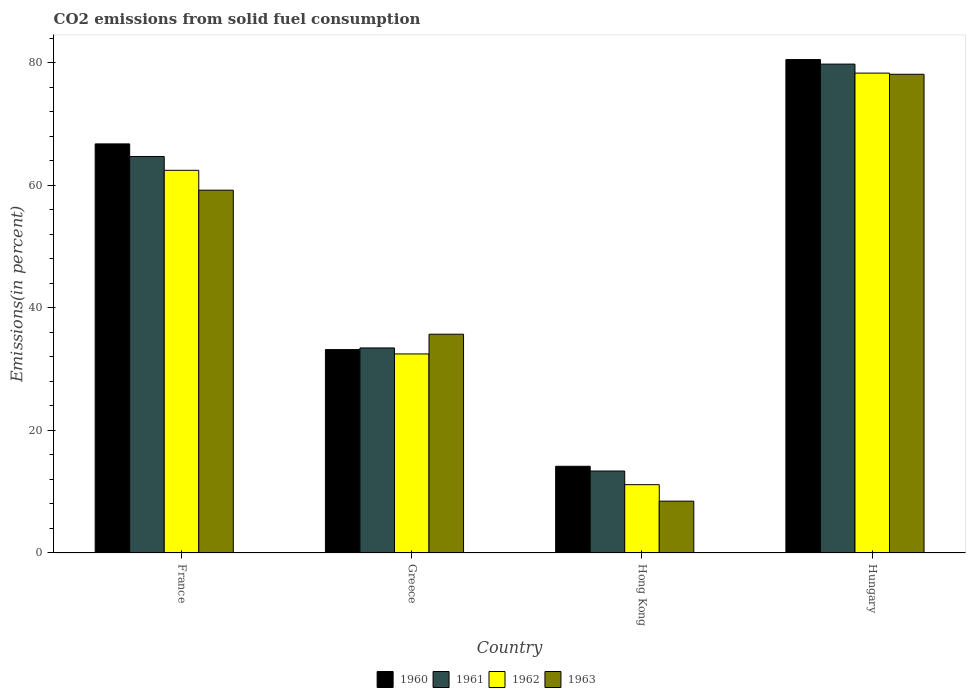How many different coloured bars are there?
Give a very brief answer. 4. Are the number of bars per tick equal to the number of legend labels?
Ensure brevity in your answer.  Yes. Are the number of bars on each tick of the X-axis equal?
Provide a succinct answer. Yes. How many bars are there on the 1st tick from the left?
Your answer should be compact. 4. What is the label of the 1st group of bars from the left?
Your answer should be compact. France. In how many cases, is the number of bars for a given country not equal to the number of legend labels?
Make the answer very short. 0. What is the total CO2 emitted in 1962 in Hungary?
Make the answer very short. 78.28. Across all countries, what is the maximum total CO2 emitted in 1961?
Provide a short and direct response. 79.75. Across all countries, what is the minimum total CO2 emitted in 1961?
Keep it short and to the point. 13.37. In which country was the total CO2 emitted in 1962 maximum?
Provide a succinct answer. Hungary. In which country was the total CO2 emitted in 1962 minimum?
Give a very brief answer. Hong Kong. What is the total total CO2 emitted in 1963 in the graph?
Ensure brevity in your answer.  181.41. What is the difference between the total CO2 emitted in 1960 in France and that in Greece?
Give a very brief answer. 33.55. What is the difference between the total CO2 emitted in 1962 in Hungary and the total CO2 emitted in 1960 in France?
Your answer should be compact. 11.55. What is the average total CO2 emitted in 1963 per country?
Offer a terse response. 45.35. What is the difference between the total CO2 emitted of/in 1960 and total CO2 emitted of/in 1961 in Greece?
Keep it short and to the point. -0.27. In how many countries, is the total CO2 emitted in 1962 greater than 16 %?
Keep it short and to the point. 3. What is the ratio of the total CO2 emitted in 1963 in Greece to that in Hong Kong?
Your response must be concise. 4.22. Is the difference between the total CO2 emitted in 1960 in Greece and Hong Kong greater than the difference between the total CO2 emitted in 1961 in Greece and Hong Kong?
Keep it short and to the point. No. What is the difference between the highest and the second highest total CO2 emitted in 1960?
Your answer should be compact. 47.31. What is the difference between the highest and the lowest total CO2 emitted in 1963?
Keep it short and to the point. 69.63. How many bars are there?
Offer a terse response. 16. Does the graph contain any zero values?
Offer a terse response. No. Does the graph contain grids?
Provide a short and direct response. No. How are the legend labels stacked?
Make the answer very short. Horizontal. What is the title of the graph?
Make the answer very short. CO2 emissions from solid fuel consumption. Does "1971" appear as one of the legend labels in the graph?
Give a very brief answer. No. What is the label or title of the Y-axis?
Ensure brevity in your answer.  Emissions(in percent). What is the Emissions(in percent) of 1960 in France?
Give a very brief answer. 66.73. What is the Emissions(in percent) in 1961 in France?
Offer a terse response. 64.68. What is the Emissions(in percent) of 1962 in France?
Ensure brevity in your answer.  62.42. What is the Emissions(in percent) in 1963 in France?
Provide a succinct answer. 59.18. What is the Emissions(in percent) in 1960 in Greece?
Ensure brevity in your answer.  33.18. What is the Emissions(in percent) of 1961 in Greece?
Provide a succinct answer. 33.45. What is the Emissions(in percent) of 1962 in Greece?
Provide a short and direct response. 32.47. What is the Emissions(in percent) of 1963 in Greece?
Your answer should be very brief. 35.69. What is the Emissions(in percent) of 1960 in Hong Kong?
Offer a terse response. 14.14. What is the Emissions(in percent) in 1961 in Hong Kong?
Your answer should be very brief. 13.37. What is the Emissions(in percent) of 1962 in Hong Kong?
Provide a succinct answer. 11.14. What is the Emissions(in percent) of 1963 in Hong Kong?
Your response must be concise. 8.46. What is the Emissions(in percent) in 1960 in Hungary?
Make the answer very short. 80.49. What is the Emissions(in percent) of 1961 in Hungary?
Give a very brief answer. 79.75. What is the Emissions(in percent) in 1962 in Hungary?
Keep it short and to the point. 78.28. What is the Emissions(in percent) in 1963 in Hungary?
Offer a terse response. 78.09. Across all countries, what is the maximum Emissions(in percent) of 1960?
Provide a short and direct response. 80.49. Across all countries, what is the maximum Emissions(in percent) in 1961?
Ensure brevity in your answer.  79.75. Across all countries, what is the maximum Emissions(in percent) in 1962?
Provide a succinct answer. 78.28. Across all countries, what is the maximum Emissions(in percent) in 1963?
Offer a very short reply. 78.09. Across all countries, what is the minimum Emissions(in percent) of 1960?
Provide a succinct answer. 14.14. Across all countries, what is the minimum Emissions(in percent) of 1961?
Your response must be concise. 13.37. Across all countries, what is the minimum Emissions(in percent) in 1962?
Provide a short and direct response. 11.14. Across all countries, what is the minimum Emissions(in percent) in 1963?
Your answer should be very brief. 8.46. What is the total Emissions(in percent) in 1960 in the graph?
Ensure brevity in your answer.  194.54. What is the total Emissions(in percent) in 1961 in the graph?
Provide a succinct answer. 191.24. What is the total Emissions(in percent) of 1962 in the graph?
Provide a succinct answer. 184.31. What is the total Emissions(in percent) of 1963 in the graph?
Offer a very short reply. 181.41. What is the difference between the Emissions(in percent) of 1960 in France and that in Greece?
Your response must be concise. 33.55. What is the difference between the Emissions(in percent) in 1961 in France and that in Greece?
Keep it short and to the point. 31.23. What is the difference between the Emissions(in percent) in 1962 in France and that in Greece?
Your response must be concise. 29.95. What is the difference between the Emissions(in percent) of 1963 in France and that in Greece?
Your answer should be very brief. 23.49. What is the difference between the Emissions(in percent) in 1960 in France and that in Hong Kong?
Keep it short and to the point. 52.59. What is the difference between the Emissions(in percent) in 1961 in France and that in Hong Kong?
Offer a terse response. 51.31. What is the difference between the Emissions(in percent) in 1962 in France and that in Hong Kong?
Make the answer very short. 51.28. What is the difference between the Emissions(in percent) in 1963 in France and that in Hong Kong?
Your response must be concise. 50.73. What is the difference between the Emissions(in percent) of 1960 in France and that in Hungary?
Ensure brevity in your answer.  -13.76. What is the difference between the Emissions(in percent) in 1961 in France and that in Hungary?
Your answer should be very brief. -15.07. What is the difference between the Emissions(in percent) in 1962 in France and that in Hungary?
Offer a very short reply. -15.86. What is the difference between the Emissions(in percent) in 1963 in France and that in Hungary?
Offer a very short reply. -18.91. What is the difference between the Emissions(in percent) of 1960 in Greece and that in Hong Kong?
Give a very brief answer. 19.03. What is the difference between the Emissions(in percent) in 1961 in Greece and that in Hong Kong?
Your answer should be compact. 20.08. What is the difference between the Emissions(in percent) of 1962 in Greece and that in Hong Kong?
Your answer should be compact. 21.32. What is the difference between the Emissions(in percent) of 1963 in Greece and that in Hong Kong?
Keep it short and to the point. 27.23. What is the difference between the Emissions(in percent) in 1960 in Greece and that in Hungary?
Keep it short and to the point. -47.31. What is the difference between the Emissions(in percent) of 1961 in Greece and that in Hungary?
Your response must be concise. -46.3. What is the difference between the Emissions(in percent) of 1962 in Greece and that in Hungary?
Offer a terse response. -45.81. What is the difference between the Emissions(in percent) in 1963 in Greece and that in Hungary?
Your response must be concise. -42.4. What is the difference between the Emissions(in percent) of 1960 in Hong Kong and that in Hungary?
Give a very brief answer. -66.35. What is the difference between the Emissions(in percent) of 1961 in Hong Kong and that in Hungary?
Provide a short and direct response. -66.38. What is the difference between the Emissions(in percent) in 1962 in Hong Kong and that in Hungary?
Offer a very short reply. -67.13. What is the difference between the Emissions(in percent) of 1963 in Hong Kong and that in Hungary?
Provide a succinct answer. -69.63. What is the difference between the Emissions(in percent) of 1960 in France and the Emissions(in percent) of 1961 in Greece?
Keep it short and to the point. 33.29. What is the difference between the Emissions(in percent) in 1960 in France and the Emissions(in percent) in 1962 in Greece?
Your answer should be very brief. 34.26. What is the difference between the Emissions(in percent) of 1960 in France and the Emissions(in percent) of 1963 in Greece?
Give a very brief answer. 31.05. What is the difference between the Emissions(in percent) of 1961 in France and the Emissions(in percent) of 1962 in Greece?
Offer a terse response. 32.21. What is the difference between the Emissions(in percent) in 1961 in France and the Emissions(in percent) in 1963 in Greece?
Provide a succinct answer. 28.99. What is the difference between the Emissions(in percent) of 1962 in France and the Emissions(in percent) of 1963 in Greece?
Provide a short and direct response. 26.74. What is the difference between the Emissions(in percent) of 1960 in France and the Emissions(in percent) of 1961 in Hong Kong?
Keep it short and to the point. 53.36. What is the difference between the Emissions(in percent) of 1960 in France and the Emissions(in percent) of 1962 in Hong Kong?
Ensure brevity in your answer.  55.59. What is the difference between the Emissions(in percent) of 1960 in France and the Emissions(in percent) of 1963 in Hong Kong?
Offer a terse response. 58.28. What is the difference between the Emissions(in percent) of 1961 in France and the Emissions(in percent) of 1962 in Hong Kong?
Offer a terse response. 53.53. What is the difference between the Emissions(in percent) in 1961 in France and the Emissions(in percent) in 1963 in Hong Kong?
Make the answer very short. 56.22. What is the difference between the Emissions(in percent) of 1962 in France and the Emissions(in percent) of 1963 in Hong Kong?
Your answer should be very brief. 53.97. What is the difference between the Emissions(in percent) in 1960 in France and the Emissions(in percent) in 1961 in Hungary?
Your answer should be very brief. -13.02. What is the difference between the Emissions(in percent) in 1960 in France and the Emissions(in percent) in 1962 in Hungary?
Provide a short and direct response. -11.55. What is the difference between the Emissions(in percent) in 1960 in France and the Emissions(in percent) in 1963 in Hungary?
Your answer should be compact. -11.36. What is the difference between the Emissions(in percent) of 1961 in France and the Emissions(in percent) of 1962 in Hungary?
Give a very brief answer. -13.6. What is the difference between the Emissions(in percent) of 1961 in France and the Emissions(in percent) of 1963 in Hungary?
Your answer should be compact. -13.41. What is the difference between the Emissions(in percent) of 1962 in France and the Emissions(in percent) of 1963 in Hungary?
Keep it short and to the point. -15.67. What is the difference between the Emissions(in percent) of 1960 in Greece and the Emissions(in percent) of 1961 in Hong Kong?
Keep it short and to the point. 19.81. What is the difference between the Emissions(in percent) in 1960 in Greece and the Emissions(in percent) in 1962 in Hong Kong?
Your answer should be very brief. 22.03. What is the difference between the Emissions(in percent) of 1960 in Greece and the Emissions(in percent) of 1963 in Hong Kong?
Your response must be concise. 24.72. What is the difference between the Emissions(in percent) in 1961 in Greece and the Emissions(in percent) in 1962 in Hong Kong?
Your answer should be compact. 22.3. What is the difference between the Emissions(in percent) in 1961 in Greece and the Emissions(in percent) in 1963 in Hong Kong?
Make the answer very short. 24.99. What is the difference between the Emissions(in percent) in 1962 in Greece and the Emissions(in percent) in 1963 in Hong Kong?
Give a very brief answer. 24.01. What is the difference between the Emissions(in percent) in 1960 in Greece and the Emissions(in percent) in 1961 in Hungary?
Provide a short and direct response. -46.57. What is the difference between the Emissions(in percent) in 1960 in Greece and the Emissions(in percent) in 1962 in Hungary?
Offer a very short reply. -45.1. What is the difference between the Emissions(in percent) in 1960 in Greece and the Emissions(in percent) in 1963 in Hungary?
Provide a succinct answer. -44.91. What is the difference between the Emissions(in percent) of 1961 in Greece and the Emissions(in percent) of 1962 in Hungary?
Offer a terse response. -44.83. What is the difference between the Emissions(in percent) of 1961 in Greece and the Emissions(in percent) of 1963 in Hungary?
Keep it short and to the point. -44.64. What is the difference between the Emissions(in percent) of 1962 in Greece and the Emissions(in percent) of 1963 in Hungary?
Your answer should be compact. -45.62. What is the difference between the Emissions(in percent) of 1960 in Hong Kong and the Emissions(in percent) of 1961 in Hungary?
Keep it short and to the point. -65.6. What is the difference between the Emissions(in percent) of 1960 in Hong Kong and the Emissions(in percent) of 1962 in Hungary?
Keep it short and to the point. -64.13. What is the difference between the Emissions(in percent) of 1960 in Hong Kong and the Emissions(in percent) of 1963 in Hungary?
Offer a terse response. -63.94. What is the difference between the Emissions(in percent) in 1961 in Hong Kong and the Emissions(in percent) in 1962 in Hungary?
Your response must be concise. -64.91. What is the difference between the Emissions(in percent) in 1961 in Hong Kong and the Emissions(in percent) in 1963 in Hungary?
Your response must be concise. -64.72. What is the difference between the Emissions(in percent) in 1962 in Hong Kong and the Emissions(in percent) in 1963 in Hungary?
Your answer should be compact. -66.94. What is the average Emissions(in percent) in 1960 per country?
Your answer should be compact. 48.64. What is the average Emissions(in percent) in 1961 per country?
Offer a very short reply. 47.81. What is the average Emissions(in percent) of 1962 per country?
Provide a succinct answer. 46.08. What is the average Emissions(in percent) of 1963 per country?
Ensure brevity in your answer.  45.35. What is the difference between the Emissions(in percent) of 1960 and Emissions(in percent) of 1961 in France?
Provide a short and direct response. 2.06. What is the difference between the Emissions(in percent) in 1960 and Emissions(in percent) in 1962 in France?
Provide a succinct answer. 4.31. What is the difference between the Emissions(in percent) of 1960 and Emissions(in percent) of 1963 in France?
Ensure brevity in your answer.  7.55. What is the difference between the Emissions(in percent) of 1961 and Emissions(in percent) of 1962 in France?
Offer a terse response. 2.25. What is the difference between the Emissions(in percent) of 1961 and Emissions(in percent) of 1963 in France?
Offer a terse response. 5.49. What is the difference between the Emissions(in percent) of 1962 and Emissions(in percent) of 1963 in France?
Provide a short and direct response. 3.24. What is the difference between the Emissions(in percent) in 1960 and Emissions(in percent) in 1961 in Greece?
Make the answer very short. -0.27. What is the difference between the Emissions(in percent) in 1960 and Emissions(in percent) in 1962 in Greece?
Ensure brevity in your answer.  0.71. What is the difference between the Emissions(in percent) in 1960 and Emissions(in percent) in 1963 in Greece?
Make the answer very short. -2.51. What is the difference between the Emissions(in percent) in 1961 and Emissions(in percent) in 1962 in Greece?
Your answer should be very brief. 0.98. What is the difference between the Emissions(in percent) of 1961 and Emissions(in percent) of 1963 in Greece?
Your answer should be compact. -2.24. What is the difference between the Emissions(in percent) in 1962 and Emissions(in percent) in 1963 in Greece?
Provide a short and direct response. -3.22. What is the difference between the Emissions(in percent) of 1960 and Emissions(in percent) of 1961 in Hong Kong?
Offer a very short reply. 0.77. What is the difference between the Emissions(in percent) of 1960 and Emissions(in percent) of 1962 in Hong Kong?
Give a very brief answer. 3. What is the difference between the Emissions(in percent) in 1960 and Emissions(in percent) in 1963 in Hong Kong?
Provide a succinct answer. 5.69. What is the difference between the Emissions(in percent) in 1961 and Emissions(in percent) in 1962 in Hong Kong?
Provide a short and direct response. 2.23. What is the difference between the Emissions(in percent) in 1961 and Emissions(in percent) in 1963 in Hong Kong?
Your answer should be very brief. 4.91. What is the difference between the Emissions(in percent) in 1962 and Emissions(in percent) in 1963 in Hong Kong?
Make the answer very short. 2.69. What is the difference between the Emissions(in percent) in 1960 and Emissions(in percent) in 1961 in Hungary?
Provide a short and direct response. 0.74. What is the difference between the Emissions(in percent) of 1960 and Emissions(in percent) of 1962 in Hungary?
Your response must be concise. 2.21. What is the difference between the Emissions(in percent) in 1960 and Emissions(in percent) in 1963 in Hungary?
Your answer should be very brief. 2.4. What is the difference between the Emissions(in percent) in 1961 and Emissions(in percent) in 1962 in Hungary?
Keep it short and to the point. 1.47. What is the difference between the Emissions(in percent) of 1961 and Emissions(in percent) of 1963 in Hungary?
Keep it short and to the point. 1.66. What is the difference between the Emissions(in percent) in 1962 and Emissions(in percent) in 1963 in Hungary?
Your response must be concise. 0.19. What is the ratio of the Emissions(in percent) of 1960 in France to that in Greece?
Make the answer very short. 2.01. What is the ratio of the Emissions(in percent) in 1961 in France to that in Greece?
Keep it short and to the point. 1.93. What is the ratio of the Emissions(in percent) of 1962 in France to that in Greece?
Your answer should be compact. 1.92. What is the ratio of the Emissions(in percent) of 1963 in France to that in Greece?
Provide a short and direct response. 1.66. What is the ratio of the Emissions(in percent) in 1960 in France to that in Hong Kong?
Your response must be concise. 4.72. What is the ratio of the Emissions(in percent) in 1961 in France to that in Hong Kong?
Your answer should be compact. 4.84. What is the ratio of the Emissions(in percent) in 1962 in France to that in Hong Kong?
Offer a terse response. 5.6. What is the ratio of the Emissions(in percent) in 1963 in France to that in Hong Kong?
Your answer should be very brief. 7. What is the ratio of the Emissions(in percent) of 1960 in France to that in Hungary?
Offer a terse response. 0.83. What is the ratio of the Emissions(in percent) in 1961 in France to that in Hungary?
Give a very brief answer. 0.81. What is the ratio of the Emissions(in percent) of 1962 in France to that in Hungary?
Provide a succinct answer. 0.8. What is the ratio of the Emissions(in percent) in 1963 in France to that in Hungary?
Offer a terse response. 0.76. What is the ratio of the Emissions(in percent) in 1960 in Greece to that in Hong Kong?
Your answer should be compact. 2.35. What is the ratio of the Emissions(in percent) in 1961 in Greece to that in Hong Kong?
Offer a very short reply. 2.5. What is the ratio of the Emissions(in percent) of 1962 in Greece to that in Hong Kong?
Keep it short and to the point. 2.91. What is the ratio of the Emissions(in percent) in 1963 in Greece to that in Hong Kong?
Your answer should be very brief. 4.22. What is the ratio of the Emissions(in percent) in 1960 in Greece to that in Hungary?
Offer a very short reply. 0.41. What is the ratio of the Emissions(in percent) in 1961 in Greece to that in Hungary?
Keep it short and to the point. 0.42. What is the ratio of the Emissions(in percent) in 1962 in Greece to that in Hungary?
Give a very brief answer. 0.41. What is the ratio of the Emissions(in percent) in 1963 in Greece to that in Hungary?
Give a very brief answer. 0.46. What is the ratio of the Emissions(in percent) of 1960 in Hong Kong to that in Hungary?
Your response must be concise. 0.18. What is the ratio of the Emissions(in percent) of 1961 in Hong Kong to that in Hungary?
Your answer should be very brief. 0.17. What is the ratio of the Emissions(in percent) of 1962 in Hong Kong to that in Hungary?
Make the answer very short. 0.14. What is the ratio of the Emissions(in percent) in 1963 in Hong Kong to that in Hungary?
Ensure brevity in your answer.  0.11. What is the difference between the highest and the second highest Emissions(in percent) of 1960?
Offer a very short reply. 13.76. What is the difference between the highest and the second highest Emissions(in percent) of 1961?
Offer a very short reply. 15.07. What is the difference between the highest and the second highest Emissions(in percent) in 1962?
Your answer should be compact. 15.86. What is the difference between the highest and the second highest Emissions(in percent) of 1963?
Your answer should be compact. 18.91. What is the difference between the highest and the lowest Emissions(in percent) of 1960?
Ensure brevity in your answer.  66.35. What is the difference between the highest and the lowest Emissions(in percent) in 1961?
Offer a terse response. 66.38. What is the difference between the highest and the lowest Emissions(in percent) of 1962?
Offer a terse response. 67.13. What is the difference between the highest and the lowest Emissions(in percent) of 1963?
Your answer should be very brief. 69.63. 